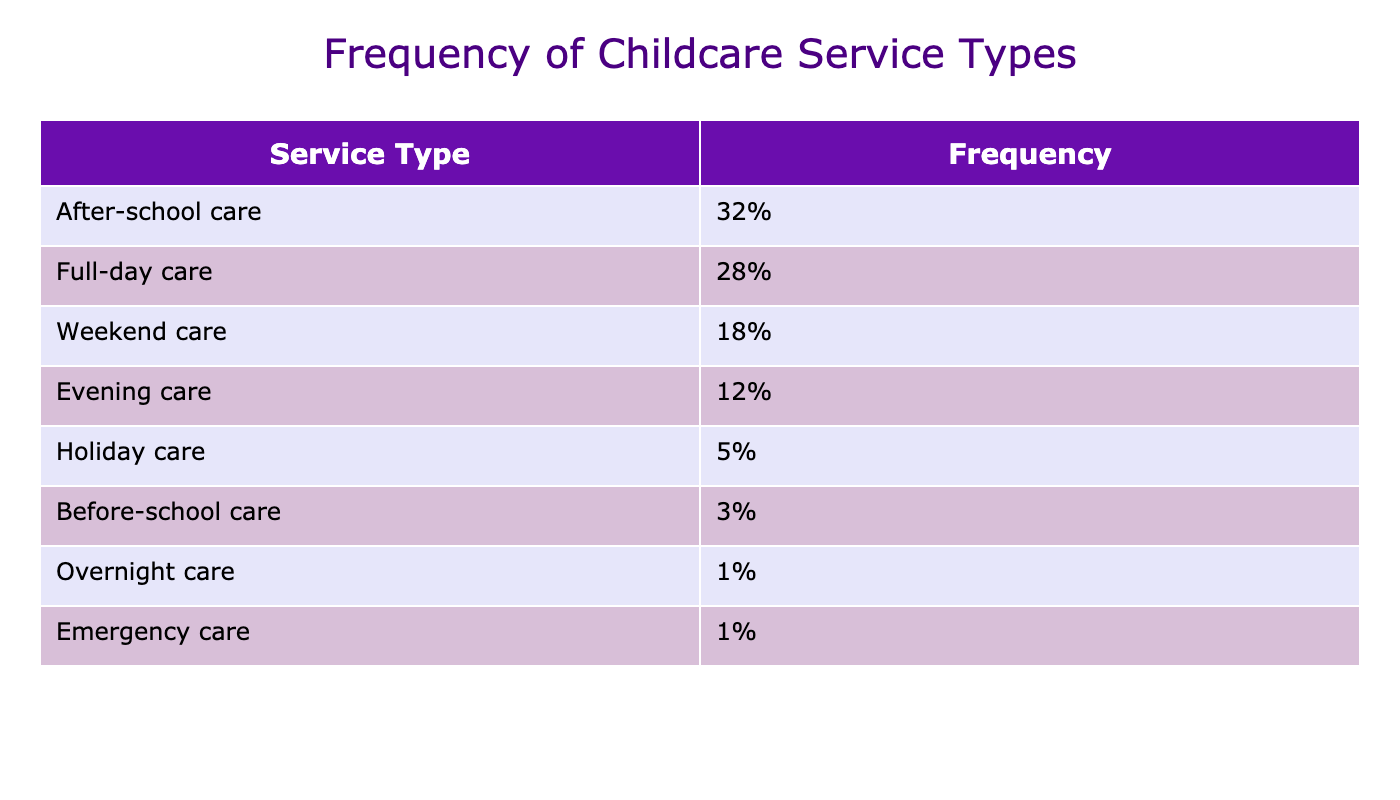What is the most requested childcare service type? The table lists the service types along with their frequencies. "After-school care" has the highest frequency of 32%, making it the most requested service.
Answer: After-school care What percentage of families requested full-day care? The table shows that full-day care has a frequency of 28%, indicating that this is the percentage of families that requested this service.
Answer: 28% Which type of care was requested the least? By reviewing the table, “Overnight care” and “Emergency care,” both with a frequency of 1%, are the least requested service types.
Answer: Overnight care and Emergency care What is the difference in frequency between after-school care and weekend care? The frequency of after-school care is 32%, and the frequency of weekend care is 18%. To find the difference, subtract 18 from 32, resulting in 14%.
Answer: 14% What is the combined percentage of before-school care and holiday care? The percentage for before-school care is 3% and for holiday care is 5%. Adding these two together gives 3 + 5 = 8%.
Answer: 8% Is evening care more frequently requested than holiday care? The table shows that evening care is requested at a frequency of 12% while holiday care is only 5%. This confirms that evening care is more frequently requested.
Answer: Yes What percentage of families prefer care during weekdays versus weekends? Weekday care includes after-school care (32%) and full-day care (28%), totaling 60%. Weekend care is requested at 18%. The difference is 60% - 18% = 42%.
Answer: 42% What percentage of families requested evening care and holiday care combined? Evening care is at 12% and holiday care is at 5%. Adding these together gives 12 + 5 = 17%.
Answer: 17% What is the average frequency of the care types listed in the table? The total frequency when adding all percentages equals 100%. Since there are 8 service types, the average frequency is 100% / 8 = 12.5%.
Answer: 12.5% Based on the table, is full-day care significantly more requested compared to before-school care? Full-day care has a frequency of 28%, while before-school care is at 3%. The difference is significant: 28% - 3% = 25%, indicating a substantial preference for full-day care.
Answer: Yes 